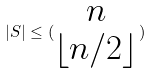Convert formula to latex. <formula><loc_0><loc_0><loc_500><loc_500>| S | \leq ( \begin{matrix} n \\ \lfloor n / 2 \rfloor \end{matrix} )</formula> 